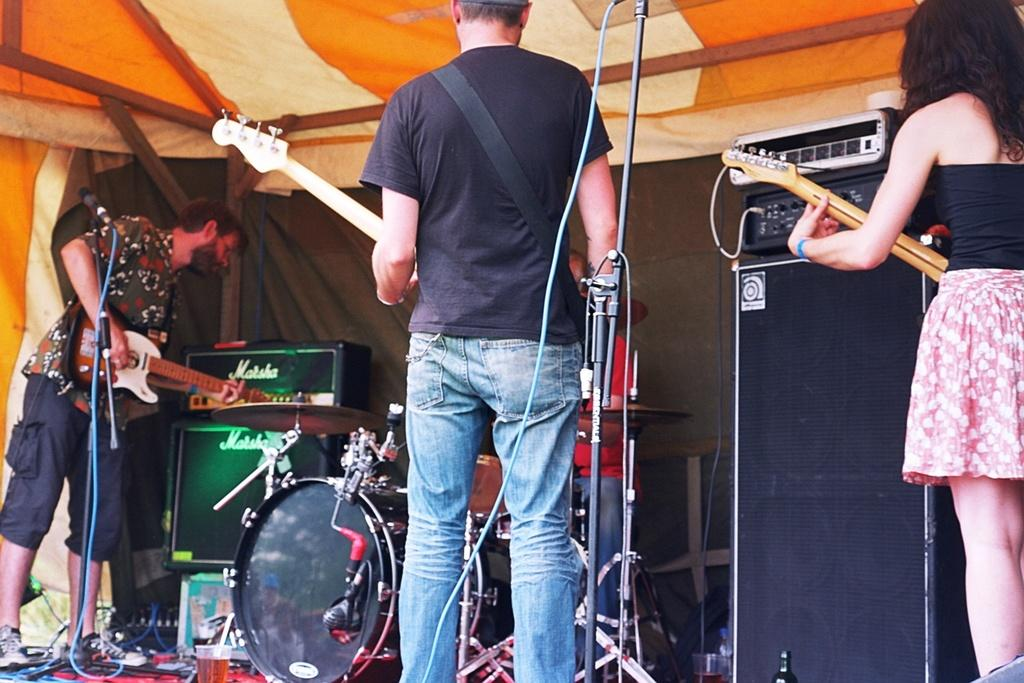How many people are in the image? There are people in the image, but the exact number is not specified. What are the people doing in the image? The people are standing in the image. What objects are the people holding in their hands? The people are holding guitars in their hands. What type of cap is the cow wearing in the image? There is no cow or cap present in the image. How many thumbs does the person on the left have in the image? The facts do not specify the number of thumbs the people have in the image. 